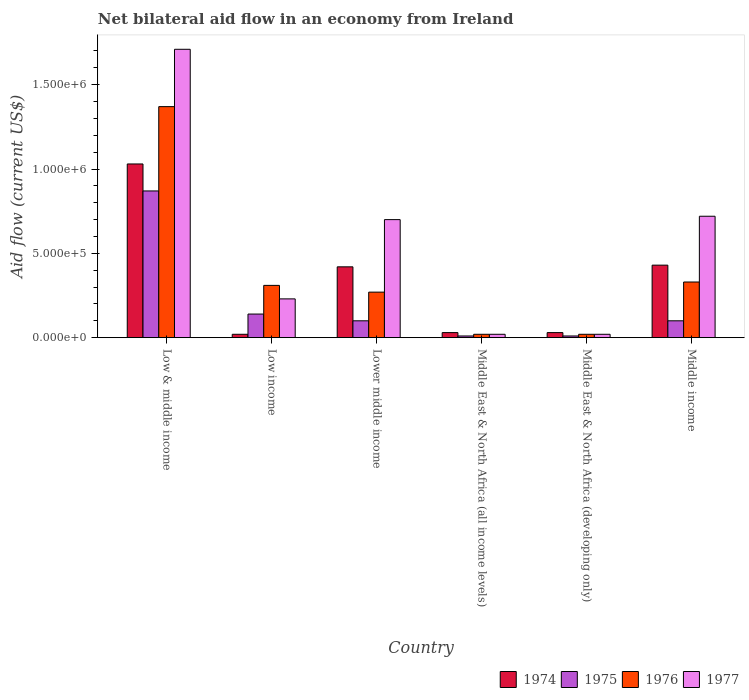How many groups of bars are there?
Offer a very short reply. 6. Are the number of bars on each tick of the X-axis equal?
Ensure brevity in your answer.  Yes. How many bars are there on the 2nd tick from the right?
Offer a terse response. 4. In how many cases, is the number of bars for a given country not equal to the number of legend labels?
Your response must be concise. 0. What is the net bilateral aid flow in 1974 in Middle East & North Africa (developing only)?
Provide a succinct answer. 3.00e+04. Across all countries, what is the maximum net bilateral aid flow in 1974?
Your answer should be very brief. 1.03e+06. Across all countries, what is the minimum net bilateral aid flow in 1976?
Give a very brief answer. 2.00e+04. In which country was the net bilateral aid flow in 1975 maximum?
Keep it short and to the point. Low & middle income. In which country was the net bilateral aid flow in 1975 minimum?
Provide a succinct answer. Middle East & North Africa (all income levels). What is the total net bilateral aid flow in 1974 in the graph?
Provide a short and direct response. 1.96e+06. What is the average net bilateral aid flow in 1976 per country?
Offer a very short reply. 3.87e+05. What is the difference between the net bilateral aid flow of/in 1977 and net bilateral aid flow of/in 1974 in Lower middle income?
Give a very brief answer. 2.80e+05. What is the ratio of the net bilateral aid flow in 1975 in Middle East & North Africa (all income levels) to that in Middle income?
Keep it short and to the point. 0.1. What is the difference between the highest and the second highest net bilateral aid flow in 1975?
Make the answer very short. 7.30e+05. What is the difference between the highest and the lowest net bilateral aid flow in 1974?
Your response must be concise. 1.01e+06. What does the 3rd bar from the left in Low income represents?
Your response must be concise. 1976. What does the 4th bar from the right in Middle East & North Africa (all income levels) represents?
Offer a terse response. 1974. Is it the case that in every country, the sum of the net bilateral aid flow in 1975 and net bilateral aid flow in 1974 is greater than the net bilateral aid flow in 1976?
Give a very brief answer. No. How many countries are there in the graph?
Keep it short and to the point. 6. Does the graph contain grids?
Make the answer very short. No. What is the title of the graph?
Make the answer very short. Net bilateral aid flow in an economy from Ireland. Does "1970" appear as one of the legend labels in the graph?
Your answer should be compact. No. What is the label or title of the Y-axis?
Your answer should be compact. Aid flow (current US$). What is the Aid flow (current US$) of 1974 in Low & middle income?
Ensure brevity in your answer.  1.03e+06. What is the Aid flow (current US$) in 1975 in Low & middle income?
Your answer should be compact. 8.70e+05. What is the Aid flow (current US$) in 1976 in Low & middle income?
Your answer should be compact. 1.37e+06. What is the Aid flow (current US$) of 1977 in Low & middle income?
Your answer should be very brief. 1.71e+06. What is the Aid flow (current US$) of 1975 in Low income?
Offer a very short reply. 1.40e+05. What is the Aid flow (current US$) of 1977 in Low income?
Your response must be concise. 2.30e+05. What is the Aid flow (current US$) in 1974 in Lower middle income?
Provide a succinct answer. 4.20e+05. What is the Aid flow (current US$) of 1975 in Lower middle income?
Offer a very short reply. 1.00e+05. What is the Aid flow (current US$) in 1974 in Middle East & North Africa (all income levels)?
Offer a very short reply. 3.00e+04. What is the Aid flow (current US$) of 1975 in Middle East & North Africa (all income levels)?
Give a very brief answer. 10000. What is the Aid flow (current US$) in 1976 in Middle East & North Africa (all income levels)?
Keep it short and to the point. 2.00e+04. What is the Aid flow (current US$) in 1977 in Middle East & North Africa (all income levels)?
Your response must be concise. 2.00e+04. What is the Aid flow (current US$) in 1974 in Middle East & North Africa (developing only)?
Give a very brief answer. 3.00e+04. What is the Aid flow (current US$) in 1977 in Middle East & North Africa (developing only)?
Ensure brevity in your answer.  2.00e+04. What is the Aid flow (current US$) in 1974 in Middle income?
Offer a very short reply. 4.30e+05. What is the Aid flow (current US$) of 1975 in Middle income?
Provide a succinct answer. 1.00e+05. What is the Aid flow (current US$) of 1977 in Middle income?
Make the answer very short. 7.20e+05. Across all countries, what is the maximum Aid flow (current US$) in 1974?
Your response must be concise. 1.03e+06. Across all countries, what is the maximum Aid flow (current US$) in 1975?
Provide a succinct answer. 8.70e+05. Across all countries, what is the maximum Aid flow (current US$) in 1976?
Offer a very short reply. 1.37e+06. Across all countries, what is the maximum Aid flow (current US$) of 1977?
Your answer should be compact. 1.71e+06. Across all countries, what is the minimum Aid flow (current US$) in 1974?
Your response must be concise. 2.00e+04. What is the total Aid flow (current US$) in 1974 in the graph?
Your response must be concise. 1.96e+06. What is the total Aid flow (current US$) of 1975 in the graph?
Make the answer very short. 1.23e+06. What is the total Aid flow (current US$) of 1976 in the graph?
Your answer should be compact. 2.32e+06. What is the total Aid flow (current US$) of 1977 in the graph?
Offer a very short reply. 3.40e+06. What is the difference between the Aid flow (current US$) of 1974 in Low & middle income and that in Low income?
Your answer should be very brief. 1.01e+06. What is the difference between the Aid flow (current US$) in 1975 in Low & middle income and that in Low income?
Your response must be concise. 7.30e+05. What is the difference between the Aid flow (current US$) of 1976 in Low & middle income and that in Low income?
Offer a terse response. 1.06e+06. What is the difference between the Aid flow (current US$) in 1977 in Low & middle income and that in Low income?
Ensure brevity in your answer.  1.48e+06. What is the difference between the Aid flow (current US$) in 1975 in Low & middle income and that in Lower middle income?
Your answer should be compact. 7.70e+05. What is the difference between the Aid flow (current US$) in 1976 in Low & middle income and that in Lower middle income?
Offer a very short reply. 1.10e+06. What is the difference between the Aid flow (current US$) in 1977 in Low & middle income and that in Lower middle income?
Your answer should be very brief. 1.01e+06. What is the difference between the Aid flow (current US$) in 1974 in Low & middle income and that in Middle East & North Africa (all income levels)?
Provide a succinct answer. 1.00e+06. What is the difference between the Aid flow (current US$) of 1975 in Low & middle income and that in Middle East & North Africa (all income levels)?
Provide a short and direct response. 8.60e+05. What is the difference between the Aid flow (current US$) in 1976 in Low & middle income and that in Middle East & North Africa (all income levels)?
Your response must be concise. 1.35e+06. What is the difference between the Aid flow (current US$) in 1977 in Low & middle income and that in Middle East & North Africa (all income levels)?
Offer a very short reply. 1.69e+06. What is the difference between the Aid flow (current US$) in 1975 in Low & middle income and that in Middle East & North Africa (developing only)?
Your answer should be compact. 8.60e+05. What is the difference between the Aid flow (current US$) of 1976 in Low & middle income and that in Middle East & North Africa (developing only)?
Your answer should be very brief. 1.35e+06. What is the difference between the Aid flow (current US$) of 1977 in Low & middle income and that in Middle East & North Africa (developing only)?
Provide a short and direct response. 1.69e+06. What is the difference between the Aid flow (current US$) of 1975 in Low & middle income and that in Middle income?
Provide a succinct answer. 7.70e+05. What is the difference between the Aid flow (current US$) in 1976 in Low & middle income and that in Middle income?
Keep it short and to the point. 1.04e+06. What is the difference between the Aid flow (current US$) of 1977 in Low & middle income and that in Middle income?
Give a very brief answer. 9.90e+05. What is the difference between the Aid flow (current US$) of 1974 in Low income and that in Lower middle income?
Offer a very short reply. -4.00e+05. What is the difference between the Aid flow (current US$) of 1975 in Low income and that in Lower middle income?
Offer a terse response. 4.00e+04. What is the difference between the Aid flow (current US$) of 1976 in Low income and that in Lower middle income?
Make the answer very short. 4.00e+04. What is the difference between the Aid flow (current US$) in 1977 in Low income and that in Lower middle income?
Offer a terse response. -4.70e+05. What is the difference between the Aid flow (current US$) of 1975 in Low income and that in Middle East & North Africa (all income levels)?
Give a very brief answer. 1.30e+05. What is the difference between the Aid flow (current US$) of 1977 in Low income and that in Middle East & North Africa (developing only)?
Offer a terse response. 2.10e+05. What is the difference between the Aid flow (current US$) in 1974 in Low income and that in Middle income?
Make the answer very short. -4.10e+05. What is the difference between the Aid flow (current US$) in 1975 in Low income and that in Middle income?
Keep it short and to the point. 4.00e+04. What is the difference between the Aid flow (current US$) in 1976 in Low income and that in Middle income?
Keep it short and to the point. -2.00e+04. What is the difference between the Aid flow (current US$) in 1977 in Low income and that in Middle income?
Ensure brevity in your answer.  -4.90e+05. What is the difference between the Aid flow (current US$) of 1974 in Lower middle income and that in Middle East & North Africa (all income levels)?
Your answer should be very brief. 3.90e+05. What is the difference between the Aid flow (current US$) in 1975 in Lower middle income and that in Middle East & North Africa (all income levels)?
Your response must be concise. 9.00e+04. What is the difference between the Aid flow (current US$) of 1976 in Lower middle income and that in Middle East & North Africa (all income levels)?
Offer a very short reply. 2.50e+05. What is the difference between the Aid flow (current US$) in 1977 in Lower middle income and that in Middle East & North Africa (all income levels)?
Keep it short and to the point. 6.80e+05. What is the difference between the Aid flow (current US$) in 1975 in Lower middle income and that in Middle East & North Africa (developing only)?
Ensure brevity in your answer.  9.00e+04. What is the difference between the Aid flow (current US$) of 1976 in Lower middle income and that in Middle East & North Africa (developing only)?
Make the answer very short. 2.50e+05. What is the difference between the Aid flow (current US$) in 1977 in Lower middle income and that in Middle East & North Africa (developing only)?
Make the answer very short. 6.80e+05. What is the difference between the Aid flow (current US$) of 1974 in Lower middle income and that in Middle income?
Offer a terse response. -10000. What is the difference between the Aid flow (current US$) in 1976 in Lower middle income and that in Middle income?
Give a very brief answer. -6.00e+04. What is the difference between the Aid flow (current US$) of 1977 in Lower middle income and that in Middle income?
Make the answer very short. -2.00e+04. What is the difference between the Aid flow (current US$) in 1975 in Middle East & North Africa (all income levels) and that in Middle East & North Africa (developing only)?
Make the answer very short. 0. What is the difference between the Aid flow (current US$) of 1974 in Middle East & North Africa (all income levels) and that in Middle income?
Provide a short and direct response. -4.00e+05. What is the difference between the Aid flow (current US$) of 1975 in Middle East & North Africa (all income levels) and that in Middle income?
Offer a terse response. -9.00e+04. What is the difference between the Aid flow (current US$) in 1976 in Middle East & North Africa (all income levels) and that in Middle income?
Provide a short and direct response. -3.10e+05. What is the difference between the Aid flow (current US$) of 1977 in Middle East & North Africa (all income levels) and that in Middle income?
Give a very brief answer. -7.00e+05. What is the difference between the Aid flow (current US$) of 1974 in Middle East & North Africa (developing only) and that in Middle income?
Provide a succinct answer. -4.00e+05. What is the difference between the Aid flow (current US$) of 1975 in Middle East & North Africa (developing only) and that in Middle income?
Your answer should be compact. -9.00e+04. What is the difference between the Aid flow (current US$) of 1976 in Middle East & North Africa (developing only) and that in Middle income?
Ensure brevity in your answer.  -3.10e+05. What is the difference between the Aid flow (current US$) of 1977 in Middle East & North Africa (developing only) and that in Middle income?
Offer a terse response. -7.00e+05. What is the difference between the Aid flow (current US$) in 1974 in Low & middle income and the Aid flow (current US$) in 1975 in Low income?
Provide a short and direct response. 8.90e+05. What is the difference between the Aid flow (current US$) in 1974 in Low & middle income and the Aid flow (current US$) in 1976 in Low income?
Keep it short and to the point. 7.20e+05. What is the difference between the Aid flow (current US$) in 1974 in Low & middle income and the Aid flow (current US$) in 1977 in Low income?
Offer a very short reply. 8.00e+05. What is the difference between the Aid flow (current US$) in 1975 in Low & middle income and the Aid flow (current US$) in 1976 in Low income?
Keep it short and to the point. 5.60e+05. What is the difference between the Aid flow (current US$) in 1975 in Low & middle income and the Aid flow (current US$) in 1977 in Low income?
Offer a very short reply. 6.40e+05. What is the difference between the Aid flow (current US$) of 1976 in Low & middle income and the Aid flow (current US$) of 1977 in Low income?
Your response must be concise. 1.14e+06. What is the difference between the Aid flow (current US$) of 1974 in Low & middle income and the Aid flow (current US$) of 1975 in Lower middle income?
Offer a very short reply. 9.30e+05. What is the difference between the Aid flow (current US$) of 1974 in Low & middle income and the Aid flow (current US$) of 1976 in Lower middle income?
Provide a short and direct response. 7.60e+05. What is the difference between the Aid flow (current US$) of 1975 in Low & middle income and the Aid flow (current US$) of 1977 in Lower middle income?
Keep it short and to the point. 1.70e+05. What is the difference between the Aid flow (current US$) of 1976 in Low & middle income and the Aid flow (current US$) of 1977 in Lower middle income?
Provide a succinct answer. 6.70e+05. What is the difference between the Aid flow (current US$) of 1974 in Low & middle income and the Aid flow (current US$) of 1975 in Middle East & North Africa (all income levels)?
Provide a short and direct response. 1.02e+06. What is the difference between the Aid flow (current US$) of 1974 in Low & middle income and the Aid flow (current US$) of 1976 in Middle East & North Africa (all income levels)?
Offer a very short reply. 1.01e+06. What is the difference between the Aid flow (current US$) of 1974 in Low & middle income and the Aid flow (current US$) of 1977 in Middle East & North Africa (all income levels)?
Your answer should be compact. 1.01e+06. What is the difference between the Aid flow (current US$) in 1975 in Low & middle income and the Aid flow (current US$) in 1976 in Middle East & North Africa (all income levels)?
Make the answer very short. 8.50e+05. What is the difference between the Aid flow (current US$) in 1975 in Low & middle income and the Aid flow (current US$) in 1977 in Middle East & North Africa (all income levels)?
Ensure brevity in your answer.  8.50e+05. What is the difference between the Aid flow (current US$) in 1976 in Low & middle income and the Aid flow (current US$) in 1977 in Middle East & North Africa (all income levels)?
Your answer should be very brief. 1.35e+06. What is the difference between the Aid flow (current US$) in 1974 in Low & middle income and the Aid flow (current US$) in 1975 in Middle East & North Africa (developing only)?
Your answer should be very brief. 1.02e+06. What is the difference between the Aid flow (current US$) of 1974 in Low & middle income and the Aid flow (current US$) of 1976 in Middle East & North Africa (developing only)?
Keep it short and to the point. 1.01e+06. What is the difference between the Aid flow (current US$) in 1974 in Low & middle income and the Aid flow (current US$) in 1977 in Middle East & North Africa (developing only)?
Provide a succinct answer. 1.01e+06. What is the difference between the Aid flow (current US$) of 1975 in Low & middle income and the Aid flow (current US$) of 1976 in Middle East & North Africa (developing only)?
Your answer should be very brief. 8.50e+05. What is the difference between the Aid flow (current US$) of 1975 in Low & middle income and the Aid flow (current US$) of 1977 in Middle East & North Africa (developing only)?
Give a very brief answer. 8.50e+05. What is the difference between the Aid flow (current US$) in 1976 in Low & middle income and the Aid flow (current US$) in 1977 in Middle East & North Africa (developing only)?
Your response must be concise. 1.35e+06. What is the difference between the Aid flow (current US$) of 1974 in Low & middle income and the Aid flow (current US$) of 1975 in Middle income?
Your answer should be compact. 9.30e+05. What is the difference between the Aid flow (current US$) in 1974 in Low & middle income and the Aid flow (current US$) in 1976 in Middle income?
Ensure brevity in your answer.  7.00e+05. What is the difference between the Aid flow (current US$) in 1974 in Low & middle income and the Aid flow (current US$) in 1977 in Middle income?
Keep it short and to the point. 3.10e+05. What is the difference between the Aid flow (current US$) in 1975 in Low & middle income and the Aid flow (current US$) in 1976 in Middle income?
Make the answer very short. 5.40e+05. What is the difference between the Aid flow (current US$) in 1976 in Low & middle income and the Aid flow (current US$) in 1977 in Middle income?
Your answer should be compact. 6.50e+05. What is the difference between the Aid flow (current US$) in 1974 in Low income and the Aid flow (current US$) in 1977 in Lower middle income?
Offer a terse response. -6.80e+05. What is the difference between the Aid flow (current US$) in 1975 in Low income and the Aid flow (current US$) in 1976 in Lower middle income?
Give a very brief answer. -1.30e+05. What is the difference between the Aid flow (current US$) of 1975 in Low income and the Aid flow (current US$) of 1977 in Lower middle income?
Keep it short and to the point. -5.60e+05. What is the difference between the Aid flow (current US$) of 1976 in Low income and the Aid flow (current US$) of 1977 in Lower middle income?
Keep it short and to the point. -3.90e+05. What is the difference between the Aid flow (current US$) in 1974 in Low income and the Aid flow (current US$) in 1975 in Middle East & North Africa (all income levels)?
Make the answer very short. 10000. What is the difference between the Aid flow (current US$) of 1974 in Low income and the Aid flow (current US$) of 1976 in Middle East & North Africa (all income levels)?
Keep it short and to the point. 0. What is the difference between the Aid flow (current US$) in 1974 in Low income and the Aid flow (current US$) in 1977 in Middle East & North Africa (all income levels)?
Ensure brevity in your answer.  0. What is the difference between the Aid flow (current US$) in 1975 in Low income and the Aid flow (current US$) in 1976 in Middle East & North Africa (all income levels)?
Ensure brevity in your answer.  1.20e+05. What is the difference between the Aid flow (current US$) of 1975 in Low income and the Aid flow (current US$) of 1977 in Middle East & North Africa (all income levels)?
Keep it short and to the point. 1.20e+05. What is the difference between the Aid flow (current US$) of 1976 in Low income and the Aid flow (current US$) of 1977 in Middle East & North Africa (all income levels)?
Your answer should be compact. 2.90e+05. What is the difference between the Aid flow (current US$) of 1974 in Low income and the Aid flow (current US$) of 1975 in Middle East & North Africa (developing only)?
Ensure brevity in your answer.  10000. What is the difference between the Aid flow (current US$) in 1974 in Low income and the Aid flow (current US$) in 1976 in Middle East & North Africa (developing only)?
Provide a short and direct response. 0. What is the difference between the Aid flow (current US$) in 1975 in Low income and the Aid flow (current US$) in 1977 in Middle East & North Africa (developing only)?
Provide a succinct answer. 1.20e+05. What is the difference between the Aid flow (current US$) in 1976 in Low income and the Aid flow (current US$) in 1977 in Middle East & North Africa (developing only)?
Your response must be concise. 2.90e+05. What is the difference between the Aid flow (current US$) in 1974 in Low income and the Aid flow (current US$) in 1975 in Middle income?
Your answer should be very brief. -8.00e+04. What is the difference between the Aid flow (current US$) of 1974 in Low income and the Aid flow (current US$) of 1976 in Middle income?
Ensure brevity in your answer.  -3.10e+05. What is the difference between the Aid flow (current US$) of 1974 in Low income and the Aid flow (current US$) of 1977 in Middle income?
Offer a terse response. -7.00e+05. What is the difference between the Aid flow (current US$) of 1975 in Low income and the Aid flow (current US$) of 1976 in Middle income?
Your response must be concise. -1.90e+05. What is the difference between the Aid flow (current US$) in 1975 in Low income and the Aid flow (current US$) in 1977 in Middle income?
Give a very brief answer. -5.80e+05. What is the difference between the Aid flow (current US$) of 1976 in Low income and the Aid flow (current US$) of 1977 in Middle income?
Your answer should be very brief. -4.10e+05. What is the difference between the Aid flow (current US$) in 1974 in Lower middle income and the Aid flow (current US$) in 1975 in Middle East & North Africa (all income levels)?
Provide a short and direct response. 4.10e+05. What is the difference between the Aid flow (current US$) in 1974 in Lower middle income and the Aid flow (current US$) in 1977 in Middle East & North Africa (all income levels)?
Keep it short and to the point. 4.00e+05. What is the difference between the Aid flow (current US$) of 1975 in Lower middle income and the Aid flow (current US$) of 1977 in Middle East & North Africa (all income levels)?
Give a very brief answer. 8.00e+04. What is the difference between the Aid flow (current US$) in 1976 in Lower middle income and the Aid flow (current US$) in 1977 in Middle East & North Africa (all income levels)?
Provide a succinct answer. 2.50e+05. What is the difference between the Aid flow (current US$) of 1974 in Lower middle income and the Aid flow (current US$) of 1976 in Middle East & North Africa (developing only)?
Your response must be concise. 4.00e+05. What is the difference between the Aid flow (current US$) in 1974 in Lower middle income and the Aid flow (current US$) in 1977 in Middle East & North Africa (developing only)?
Provide a succinct answer. 4.00e+05. What is the difference between the Aid flow (current US$) in 1975 in Lower middle income and the Aid flow (current US$) in 1977 in Middle East & North Africa (developing only)?
Your answer should be compact. 8.00e+04. What is the difference between the Aid flow (current US$) of 1974 in Lower middle income and the Aid flow (current US$) of 1976 in Middle income?
Your answer should be compact. 9.00e+04. What is the difference between the Aid flow (current US$) in 1974 in Lower middle income and the Aid flow (current US$) in 1977 in Middle income?
Your answer should be very brief. -3.00e+05. What is the difference between the Aid flow (current US$) in 1975 in Lower middle income and the Aid flow (current US$) in 1976 in Middle income?
Your response must be concise. -2.30e+05. What is the difference between the Aid flow (current US$) in 1975 in Lower middle income and the Aid flow (current US$) in 1977 in Middle income?
Your answer should be compact. -6.20e+05. What is the difference between the Aid flow (current US$) of 1976 in Lower middle income and the Aid flow (current US$) of 1977 in Middle income?
Make the answer very short. -4.50e+05. What is the difference between the Aid flow (current US$) of 1975 in Middle East & North Africa (all income levels) and the Aid flow (current US$) of 1977 in Middle East & North Africa (developing only)?
Make the answer very short. -10000. What is the difference between the Aid flow (current US$) in 1976 in Middle East & North Africa (all income levels) and the Aid flow (current US$) in 1977 in Middle East & North Africa (developing only)?
Make the answer very short. 0. What is the difference between the Aid flow (current US$) in 1974 in Middle East & North Africa (all income levels) and the Aid flow (current US$) in 1975 in Middle income?
Provide a succinct answer. -7.00e+04. What is the difference between the Aid flow (current US$) of 1974 in Middle East & North Africa (all income levels) and the Aid flow (current US$) of 1976 in Middle income?
Offer a terse response. -3.00e+05. What is the difference between the Aid flow (current US$) of 1974 in Middle East & North Africa (all income levels) and the Aid flow (current US$) of 1977 in Middle income?
Your answer should be very brief. -6.90e+05. What is the difference between the Aid flow (current US$) in 1975 in Middle East & North Africa (all income levels) and the Aid flow (current US$) in 1976 in Middle income?
Provide a short and direct response. -3.20e+05. What is the difference between the Aid flow (current US$) of 1975 in Middle East & North Africa (all income levels) and the Aid flow (current US$) of 1977 in Middle income?
Provide a succinct answer. -7.10e+05. What is the difference between the Aid flow (current US$) of 1976 in Middle East & North Africa (all income levels) and the Aid flow (current US$) of 1977 in Middle income?
Provide a short and direct response. -7.00e+05. What is the difference between the Aid flow (current US$) in 1974 in Middle East & North Africa (developing only) and the Aid flow (current US$) in 1975 in Middle income?
Keep it short and to the point. -7.00e+04. What is the difference between the Aid flow (current US$) of 1974 in Middle East & North Africa (developing only) and the Aid flow (current US$) of 1976 in Middle income?
Your answer should be compact. -3.00e+05. What is the difference between the Aid flow (current US$) of 1974 in Middle East & North Africa (developing only) and the Aid flow (current US$) of 1977 in Middle income?
Provide a succinct answer. -6.90e+05. What is the difference between the Aid flow (current US$) in 1975 in Middle East & North Africa (developing only) and the Aid flow (current US$) in 1976 in Middle income?
Offer a very short reply. -3.20e+05. What is the difference between the Aid flow (current US$) of 1975 in Middle East & North Africa (developing only) and the Aid flow (current US$) of 1977 in Middle income?
Provide a short and direct response. -7.10e+05. What is the difference between the Aid flow (current US$) of 1976 in Middle East & North Africa (developing only) and the Aid flow (current US$) of 1977 in Middle income?
Give a very brief answer. -7.00e+05. What is the average Aid flow (current US$) in 1974 per country?
Keep it short and to the point. 3.27e+05. What is the average Aid flow (current US$) in 1975 per country?
Keep it short and to the point. 2.05e+05. What is the average Aid flow (current US$) in 1976 per country?
Make the answer very short. 3.87e+05. What is the average Aid flow (current US$) in 1977 per country?
Give a very brief answer. 5.67e+05. What is the difference between the Aid flow (current US$) in 1974 and Aid flow (current US$) in 1975 in Low & middle income?
Offer a terse response. 1.60e+05. What is the difference between the Aid flow (current US$) in 1974 and Aid flow (current US$) in 1977 in Low & middle income?
Keep it short and to the point. -6.80e+05. What is the difference between the Aid flow (current US$) of 1975 and Aid flow (current US$) of 1976 in Low & middle income?
Your answer should be compact. -5.00e+05. What is the difference between the Aid flow (current US$) of 1975 and Aid flow (current US$) of 1977 in Low & middle income?
Give a very brief answer. -8.40e+05. What is the difference between the Aid flow (current US$) of 1974 and Aid flow (current US$) of 1975 in Low income?
Offer a terse response. -1.20e+05. What is the difference between the Aid flow (current US$) in 1974 and Aid flow (current US$) in 1977 in Low income?
Ensure brevity in your answer.  -2.10e+05. What is the difference between the Aid flow (current US$) of 1975 and Aid flow (current US$) of 1976 in Low income?
Make the answer very short. -1.70e+05. What is the difference between the Aid flow (current US$) of 1974 and Aid flow (current US$) of 1977 in Lower middle income?
Provide a short and direct response. -2.80e+05. What is the difference between the Aid flow (current US$) of 1975 and Aid flow (current US$) of 1977 in Lower middle income?
Ensure brevity in your answer.  -6.00e+05. What is the difference between the Aid flow (current US$) of 1976 and Aid flow (current US$) of 1977 in Lower middle income?
Keep it short and to the point. -4.30e+05. What is the difference between the Aid flow (current US$) in 1974 and Aid flow (current US$) in 1976 in Middle East & North Africa (all income levels)?
Ensure brevity in your answer.  10000. What is the difference between the Aid flow (current US$) of 1974 and Aid flow (current US$) of 1977 in Middle East & North Africa (all income levels)?
Provide a short and direct response. 10000. What is the difference between the Aid flow (current US$) of 1976 and Aid flow (current US$) of 1977 in Middle East & North Africa (all income levels)?
Your response must be concise. 0. What is the difference between the Aid flow (current US$) of 1976 and Aid flow (current US$) of 1977 in Middle East & North Africa (developing only)?
Offer a terse response. 0. What is the difference between the Aid flow (current US$) of 1975 and Aid flow (current US$) of 1976 in Middle income?
Make the answer very short. -2.30e+05. What is the difference between the Aid flow (current US$) in 1975 and Aid flow (current US$) in 1977 in Middle income?
Your answer should be compact. -6.20e+05. What is the difference between the Aid flow (current US$) in 1976 and Aid flow (current US$) in 1977 in Middle income?
Your response must be concise. -3.90e+05. What is the ratio of the Aid flow (current US$) in 1974 in Low & middle income to that in Low income?
Provide a short and direct response. 51.5. What is the ratio of the Aid flow (current US$) in 1975 in Low & middle income to that in Low income?
Ensure brevity in your answer.  6.21. What is the ratio of the Aid flow (current US$) in 1976 in Low & middle income to that in Low income?
Offer a terse response. 4.42. What is the ratio of the Aid flow (current US$) of 1977 in Low & middle income to that in Low income?
Your answer should be very brief. 7.43. What is the ratio of the Aid flow (current US$) in 1974 in Low & middle income to that in Lower middle income?
Offer a terse response. 2.45. What is the ratio of the Aid flow (current US$) in 1975 in Low & middle income to that in Lower middle income?
Your response must be concise. 8.7. What is the ratio of the Aid flow (current US$) of 1976 in Low & middle income to that in Lower middle income?
Keep it short and to the point. 5.07. What is the ratio of the Aid flow (current US$) in 1977 in Low & middle income to that in Lower middle income?
Your response must be concise. 2.44. What is the ratio of the Aid flow (current US$) of 1974 in Low & middle income to that in Middle East & North Africa (all income levels)?
Ensure brevity in your answer.  34.33. What is the ratio of the Aid flow (current US$) in 1975 in Low & middle income to that in Middle East & North Africa (all income levels)?
Your response must be concise. 87. What is the ratio of the Aid flow (current US$) in 1976 in Low & middle income to that in Middle East & North Africa (all income levels)?
Your response must be concise. 68.5. What is the ratio of the Aid flow (current US$) of 1977 in Low & middle income to that in Middle East & North Africa (all income levels)?
Your answer should be compact. 85.5. What is the ratio of the Aid flow (current US$) of 1974 in Low & middle income to that in Middle East & North Africa (developing only)?
Provide a short and direct response. 34.33. What is the ratio of the Aid flow (current US$) of 1976 in Low & middle income to that in Middle East & North Africa (developing only)?
Provide a succinct answer. 68.5. What is the ratio of the Aid flow (current US$) in 1977 in Low & middle income to that in Middle East & North Africa (developing only)?
Offer a terse response. 85.5. What is the ratio of the Aid flow (current US$) in 1974 in Low & middle income to that in Middle income?
Your response must be concise. 2.4. What is the ratio of the Aid flow (current US$) in 1975 in Low & middle income to that in Middle income?
Ensure brevity in your answer.  8.7. What is the ratio of the Aid flow (current US$) of 1976 in Low & middle income to that in Middle income?
Keep it short and to the point. 4.15. What is the ratio of the Aid flow (current US$) in 1977 in Low & middle income to that in Middle income?
Offer a terse response. 2.38. What is the ratio of the Aid flow (current US$) of 1974 in Low income to that in Lower middle income?
Give a very brief answer. 0.05. What is the ratio of the Aid flow (current US$) of 1976 in Low income to that in Lower middle income?
Provide a succinct answer. 1.15. What is the ratio of the Aid flow (current US$) of 1977 in Low income to that in Lower middle income?
Offer a very short reply. 0.33. What is the ratio of the Aid flow (current US$) in 1976 in Low income to that in Middle East & North Africa (all income levels)?
Provide a short and direct response. 15.5. What is the ratio of the Aid flow (current US$) in 1977 in Low income to that in Middle East & North Africa (all income levels)?
Keep it short and to the point. 11.5. What is the ratio of the Aid flow (current US$) of 1975 in Low income to that in Middle East & North Africa (developing only)?
Ensure brevity in your answer.  14. What is the ratio of the Aid flow (current US$) of 1974 in Low income to that in Middle income?
Your response must be concise. 0.05. What is the ratio of the Aid flow (current US$) of 1976 in Low income to that in Middle income?
Your answer should be very brief. 0.94. What is the ratio of the Aid flow (current US$) in 1977 in Low income to that in Middle income?
Give a very brief answer. 0.32. What is the ratio of the Aid flow (current US$) in 1975 in Lower middle income to that in Middle East & North Africa (all income levels)?
Your answer should be very brief. 10. What is the ratio of the Aid flow (current US$) in 1976 in Lower middle income to that in Middle East & North Africa (all income levels)?
Provide a short and direct response. 13.5. What is the ratio of the Aid flow (current US$) in 1977 in Lower middle income to that in Middle East & North Africa (all income levels)?
Provide a short and direct response. 35. What is the ratio of the Aid flow (current US$) of 1974 in Lower middle income to that in Middle East & North Africa (developing only)?
Ensure brevity in your answer.  14. What is the ratio of the Aid flow (current US$) in 1975 in Lower middle income to that in Middle East & North Africa (developing only)?
Provide a succinct answer. 10. What is the ratio of the Aid flow (current US$) of 1976 in Lower middle income to that in Middle East & North Africa (developing only)?
Give a very brief answer. 13.5. What is the ratio of the Aid flow (current US$) of 1974 in Lower middle income to that in Middle income?
Keep it short and to the point. 0.98. What is the ratio of the Aid flow (current US$) of 1975 in Lower middle income to that in Middle income?
Ensure brevity in your answer.  1. What is the ratio of the Aid flow (current US$) of 1976 in Lower middle income to that in Middle income?
Provide a short and direct response. 0.82. What is the ratio of the Aid flow (current US$) of 1977 in Lower middle income to that in Middle income?
Ensure brevity in your answer.  0.97. What is the ratio of the Aid flow (current US$) in 1975 in Middle East & North Africa (all income levels) to that in Middle East & North Africa (developing only)?
Your response must be concise. 1. What is the ratio of the Aid flow (current US$) in 1974 in Middle East & North Africa (all income levels) to that in Middle income?
Your response must be concise. 0.07. What is the ratio of the Aid flow (current US$) of 1975 in Middle East & North Africa (all income levels) to that in Middle income?
Make the answer very short. 0.1. What is the ratio of the Aid flow (current US$) of 1976 in Middle East & North Africa (all income levels) to that in Middle income?
Keep it short and to the point. 0.06. What is the ratio of the Aid flow (current US$) in 1977 in Middle East & North Africa (all income levels) to that in Middle income?
Make the answer very short. 0.03. What is the ratio of the Aid flow (current US$) in 1974 in Middle East & North Africa (developing only) to that in Middle income?
Provide a succinct answer. 0.07. What is the ratio of the Aid flow (current US$) of 1976 in Middle East & North Africa (developing only) to that in Middle income?
Give a very brief answer. 0.06. What is the ratio of the Aid flow (current US$) in 1977 in Middle East & North Africa (developing only) to that in Middle income?
Give a very brief answer. 0.03. What is the difference between the highest and the second highest Aid flow (current US$) in 1974?
Ensure brevity in your answer.  6.00e+05. What is the difference between the highest and the second highest Aid flow (current US$) in 1975?
Ensure brevity in your answer.  7.30e+05. What is the difference between the highest and the second highest Aid flow (current US$) of 1976?
Offer a terse response. 1.04e+06. What is the difference between the highest and the second highest Aid flow (current US$) of 1977?
Ensure brevity in your answer.  9.90e+05. What is the difference between the highest and the lowest Aid flow (current US$) in 1974?
Your answer should be compact. 1.01e+06. What is the difference between the highest and the lowest Aid flow (current US$) in 1975?
Your response must be concise. 8.60e+05. What is the difference between the highest and the lowest Aid flow (current US$) in 1976?
Offer a very short reply. 1.35e+06. What is the difference between the highest and the lowest Aid flow (current US$) in 1977?
Ensure brevity in your answer.  1.69e+06. 